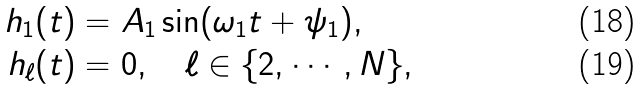Convert formula to latex. <formula><loc_0><loc_0><loc_500><loc_500>h _ { 1 } ( t ) & = A _ { 1 } \sin ( \omega _ { 1 } t + \psi _ { 1 } ) , \\ h _ { \ell } ( t ) & = 0 , \quad \ell \in \{ 2 , \cdots , N \} ,</formula> 